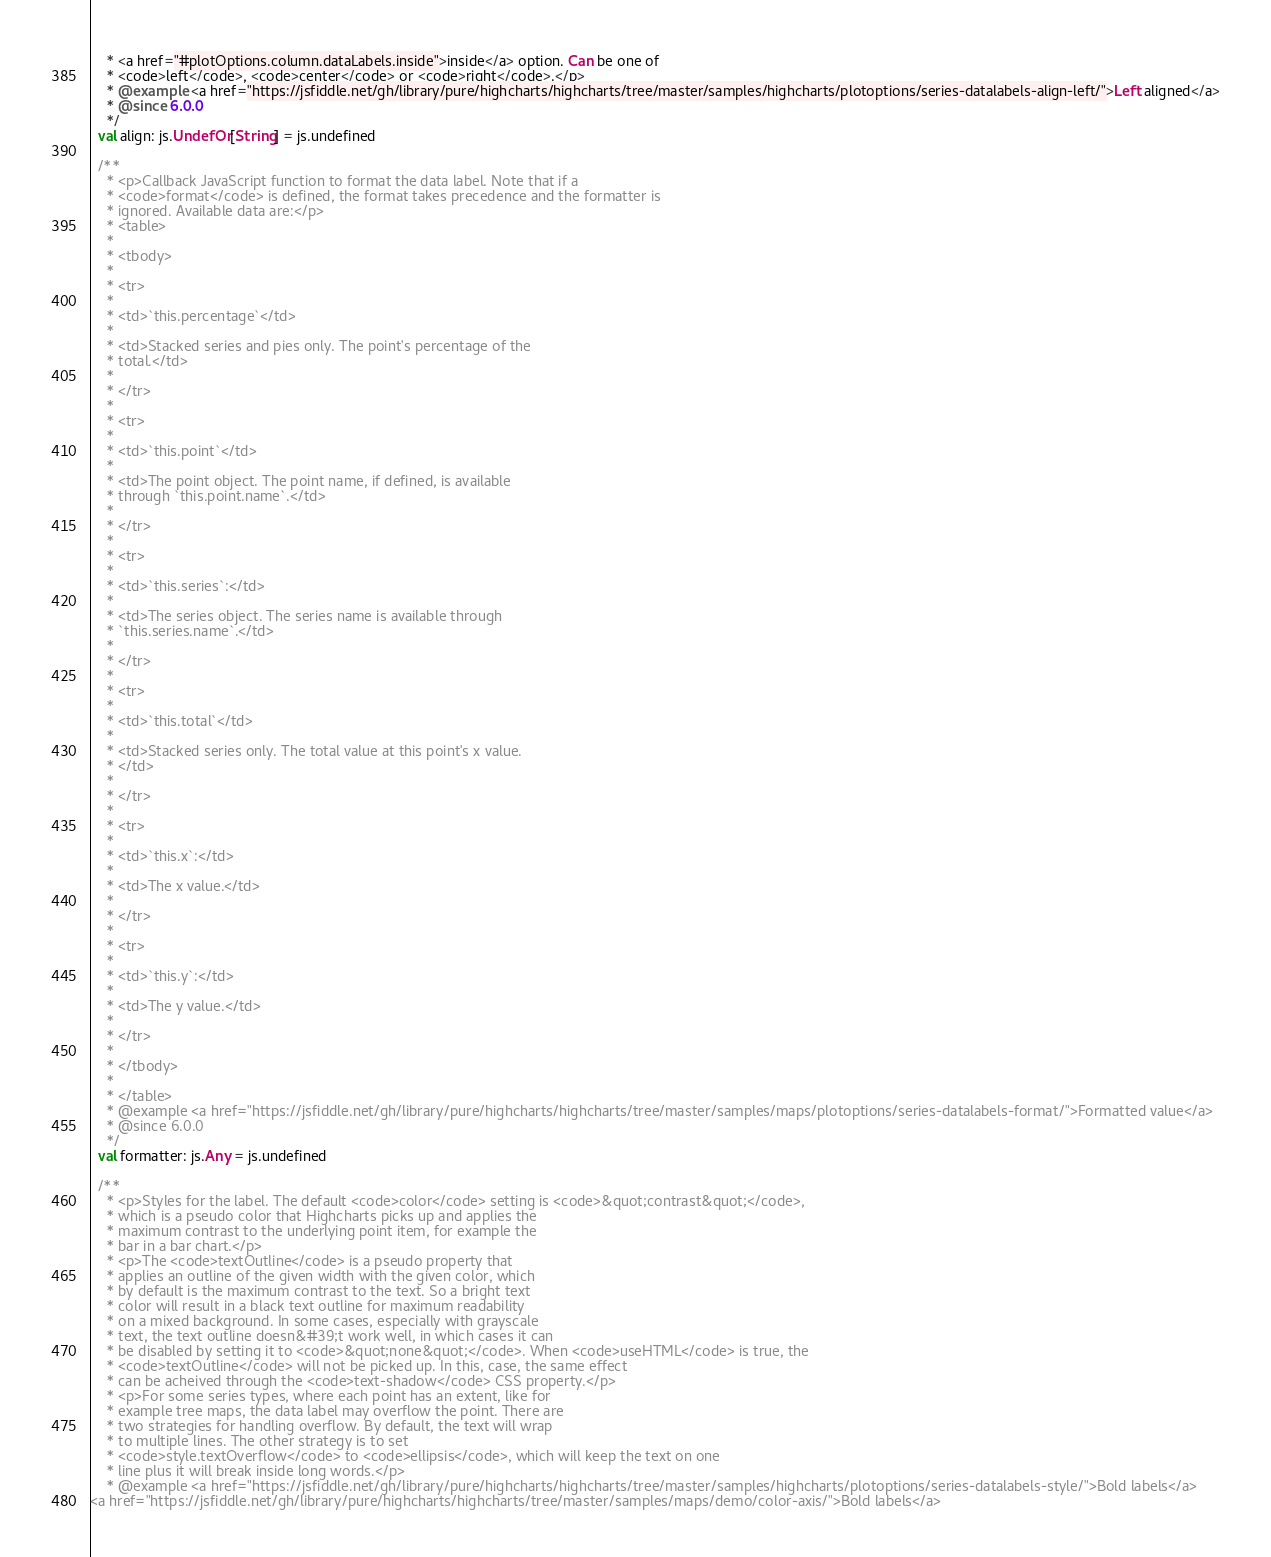<code> <loc_0><loc_0><loc_500><loc_500><_Scala_>    * <a href="#plotOptions.column.dataLabels.inside">inside</a> option. Can be one of
    * <code>left</code>, <code>center</code> or <code>right</code>.</p>
    * @example <a href="https://jsfiddle.net/gh/library/pure/highcharts/highcharts/tree/master/samples/highcharts/plotoptions/series-datalabels-align-left/">Left aligned</a>
    * @since 6.0.0
    */
  val align: js.UndefOr[String] = js.undefined

  /**
    * <p>Callback JavaScript function to format the data label. Note that if a
    * <code>format</code> is defined, the format takes precedence and the formatter is
    * ignored. Available data are:</p>
    * <table>
    * 
    * <tbody>
    * 
    * <tr>
    * 
    * <td>`this.percentage`</td>
    * 
    * <td>Stacked series and pies only. The point's percentage of the
    * total.</td>
    * 
    * </tr>
    * 
    * <tr>
    * 
    * <td>`this.point`</td>
    * 
    * <td>The point object. The point name, if defined, is available
    * through `this.point.name`.</td>
    * 
    * </tr>
    * 
    * <tr>
    * 
    * <td>`this.series`:</td>
    * 
    * <td>The series object. The series name is available through
    * `this.series.name`.</td>
    * 
    * </tr>
    * 
    * <tr>
    * 
    * <td>`this.total`</td>
    * 
    * <td>Stacked series only. The total value at this point's x value.
    * </td>
    * 
    * </tr>
    * 
    * <tr>
    * 
    * <td>`this.x`:</td>
    * 
    * <td>The x value.</td>
    * 
    * </tr>
    * 
    * <tr>
    * 
    * <td>`this.y`:</td>
    * 
    * <td>The y value.</td>
    * 
    * </tr>
    * 
    * </tbody>
    * 
    * </table>
    * @example <a href="https://jsfiddle.net/gh/library/pure/highcharts/highcharts/tree/master/samples/maps/plotoptions/series-datalabels-format/">Formatted value</a>
    * @since 6.0.0
    */
  val formatter: js.Any = js.undefined

  /**
    * <p>Styles for the label. The default <code>color</code> setting is <code>&quot;contrast&quot;</code>,
    * which is a pseudo color that Highcharts picks up and applies the
    * maximum contrast to the underlying point item, for example the
    * bar in a bar chart.</p>
    * <p>The <code>textOutline</code> is a pseudo property that
    * applies an outline of the given width with the given color, which
    * by default is the maximum contrast to the text. So a bright text
    * color will result in a black text outline for maximum readability
    * on a mixed background. In some cases, especially with grayscale
    * text, the text outline doesn&#39;t work well, in which cases it can
    * be disabled by setting it to <code>&quot;none&quot;</code>. When <code>useHTML</code> is true, the
    * <code>textOutline</code> will not be picked up. In this, case, the same effect
    * can be acheived through the <code>text-shadow</code> CSS property.</p>
    * <p>For some series types, where each point has an extent, like for
    * example tree maps, the data label may overflow the point. There are
    * two strategies for handling overflow. By default, the text will wrap
    * to multiple lines. The other strategy is to set
    * <code>style.textOverflow</code> to <code>ellipsis</code>, which will keep the text on one
    * line plus it will break inside long words.</p>
    * @example <a href="https://jsfiddle.net/gh/library/pure/highcharts/highcharts/tree/master/samples/highcharts/plotoptions/series-datalabels-style/">Bold labels</a>
<a href="https://jsfiddle.net/gh/library/pure/highcharts/highcharts/tree/master/samples/maps/demo/color-axis/">Bold labels</a></code> 